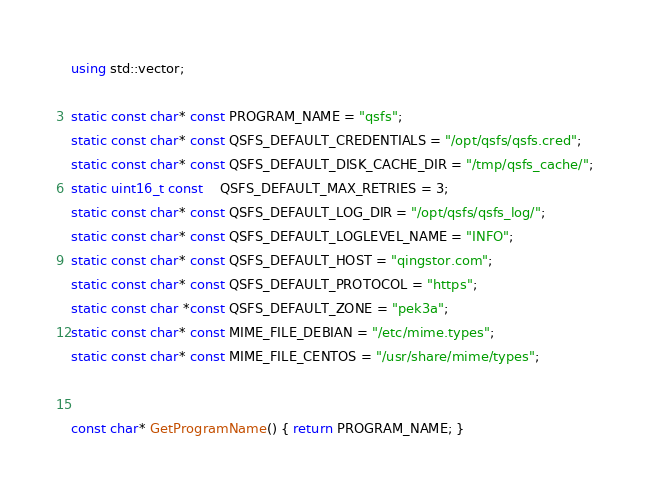Convert code to text. <code><loc_0><loc_0><loc_500><loc_500><_C++_>using std::vector;

static const char* const PROGRAM_NAME = "qsfs";
static const char* const QSFS_DEFAULT_CREDENTIALS = "/opt/qsfs/qsfs.cred";
static const char* const QSFS_DEFAULT_DISK_CACHE_DIR = "/tmp/qsfs_cache/";
static uint16_t const    QSFS_DEFAULT_MAX_RETRIES = 3;
static const char* const QSFS_DEFAULT_LOG_DIR = "/opt/qsfs/qsfs_log/";
static const char* const QSFS_DEFAULT_LOGLEVEL_NAME = "INFO";
static const char* const QSFS_DEFAULT_HOST = "qingstor.com";
static const char* const QSFS_DEFAULT_PROTOCOL = "https";
static const char *const QSFS_DEFAULT_ZONE = "pek3a";
static const char* const MIME_FILE_DEBIAN = "/etc/mime.types";
static const char* const MIME_FILE_CENTOS = "/usr/share/mime/types";


const char* GetProgramName() { return PROGRAM_NAME; }
</code> 